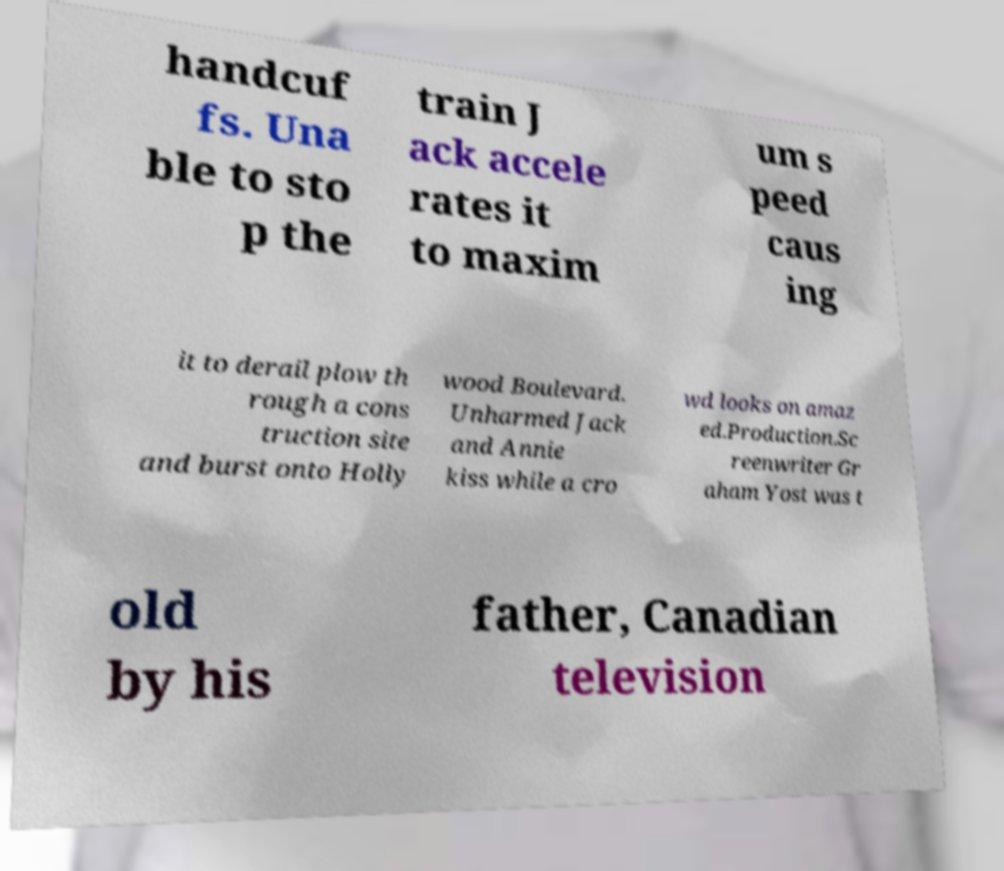Please identify and transcribe the text found in this image. handcuf fs. Una ble to sto p the train J ack accele rates it to maxim um s peed caus ing it to derail plow th rough a cons truction site and burst onto Holly wood Boulevard. Unharmed Jack and Annie kiss while a cro wd looks on amaz ed.Production.Sc reenwriter Gr aham Yost was t old by his father, Canadian television 